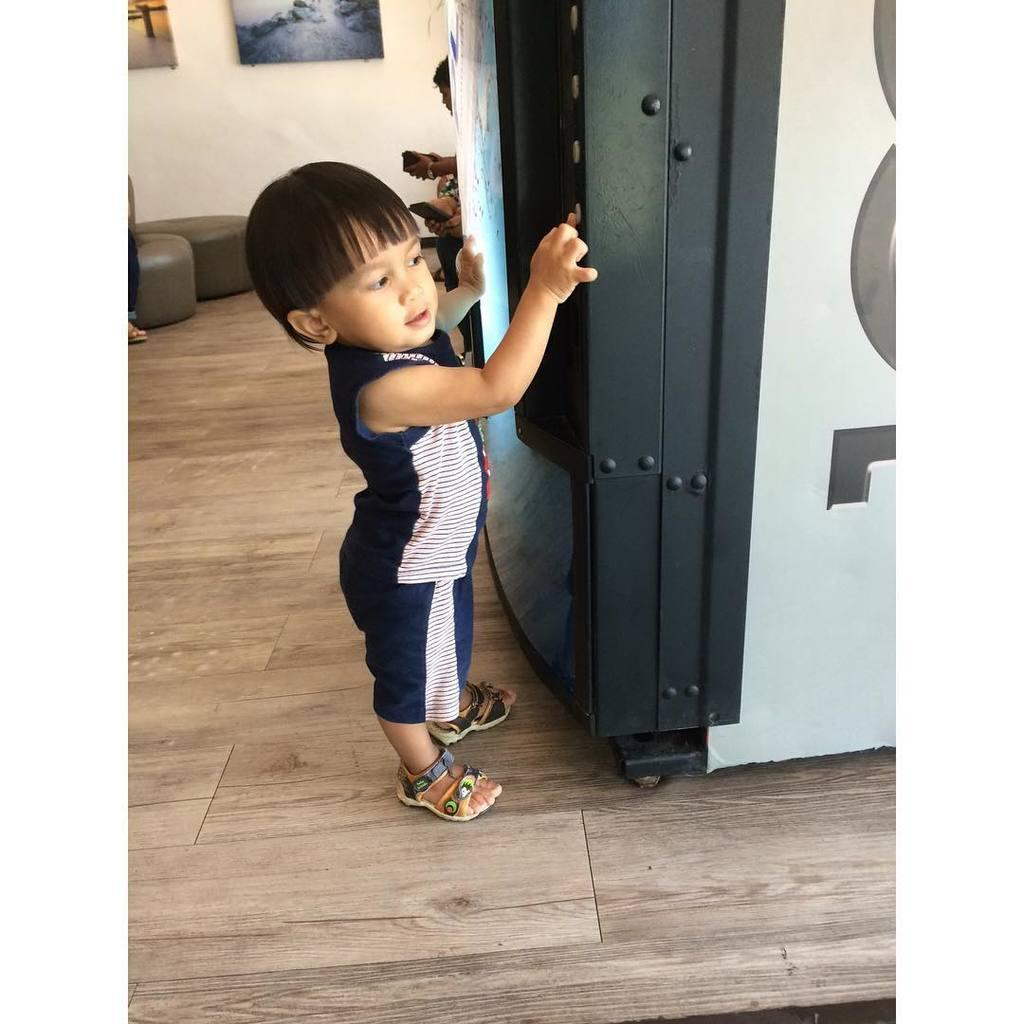What large appliance can be seen in the image? There is a refrigerator in the image. Who is present in the image? There is a boy standing in the image. What type of furniture is in the image? There is a sofa in the image. What architectural feature is visible in the image? There is a wall in the image. What type of decorative items are present in the image? There are photo frames in the image. What type of comb can be seen in the boy's hair in the image? There is no comb visible in the boy's hair in the image. What type of fang can be seen in the image? There are no fangs present in the image. 